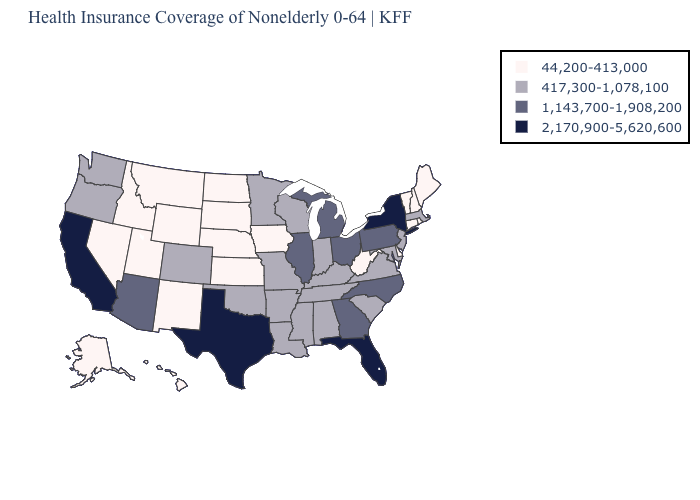Does New Mexico have the lowest value in the USA?
Write a very short answer. Yes. What is the value of Rhode Island?
Short answer required. 44,200-413,000. Is the legend a continuous bar?
Be succinct. No. What is the highest value in the MidWest ?
Answer briefly. 1,143,700-1,908,200. Among the states that border California , does Oregon have the lowest value?
Keep it brief. No. Does California have the highest value in the USA?
Give a very brief answer. Yes. What is the value of Arizona?
Quick response, please. 1,143,700-1,908,200. What is the lowest value in the USA?
Answer briefly. 44,200-413,000. Which states have the lowest value in the USA?
Give a very brief answer. Alaska, Connecticut, Delaware, Hawaii, Idaho, Iowa, Kansas, Maine, Montana, Nebraska, Nevada, New Hampshire, New Mexico, North Dakota, Rhode Island, South Dakota, Utah, Vermont, West Virginia, Wyoming. What is the highest value in states that border Florida?
Be succinct. 1,143,700-1,908,200. Name the states that have a value in the range 2,170,900-5,620,600?
Give a very brief answer. California, Florida, New York, Texas. What is the lowest value in the USA?
Answer briefly. 44,200-413,000. Among the states that border Colorado , does Oklahoma have the lowest value?
Answer briefly. No. Name the states that have a value in the range 417,300-1,078,100?
Answer briefly. Alabama, Arkansas, Colorado, Indiana, Kentucky, Louisiana, Maryland, Massachusetts, Minnesota, Mississippi, Missouri, New Jersey, Oklahoma, Oregon, South Carolina, Tennessee, Virginia, Washington, Wisconsin. 